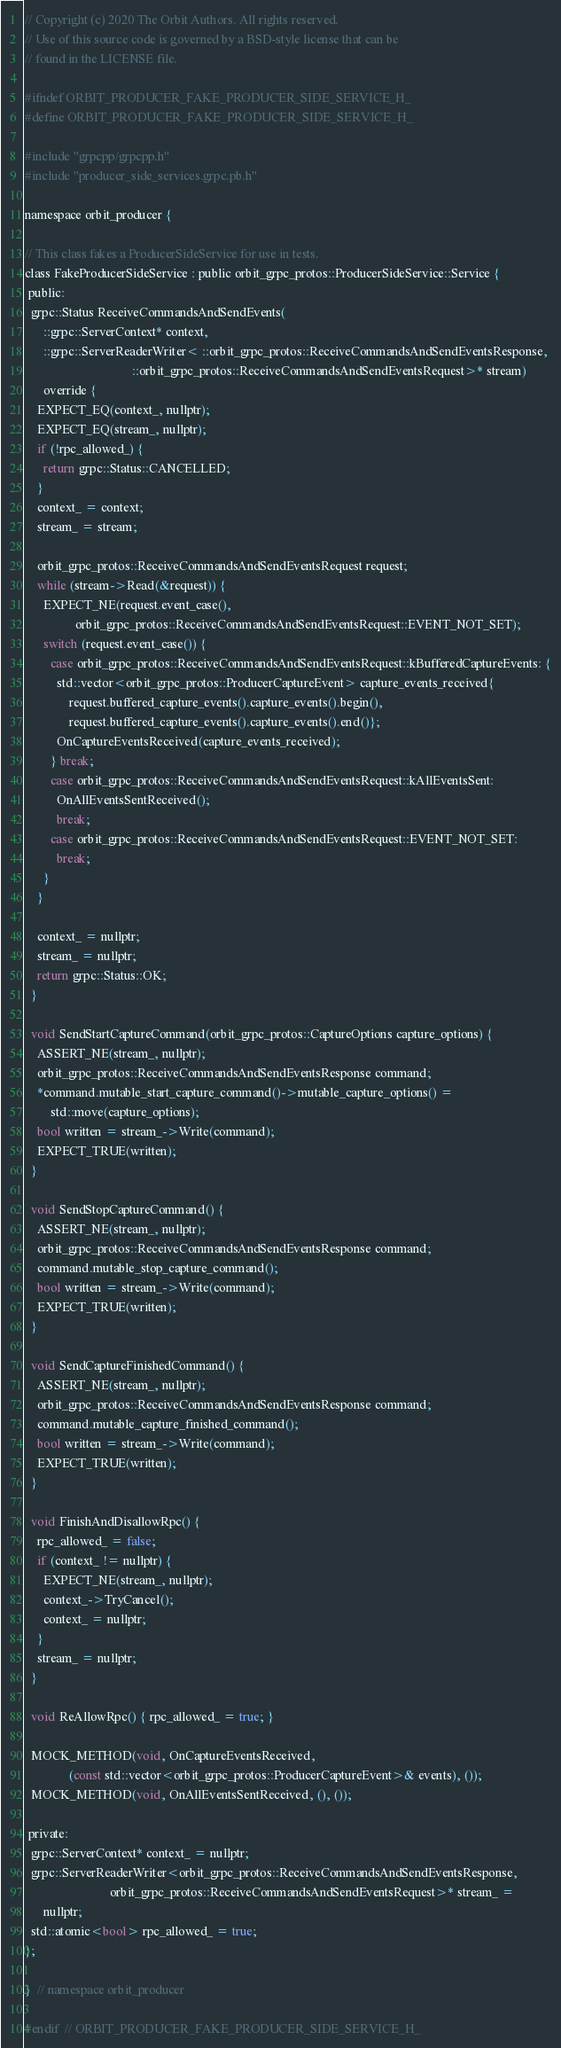Convert code to text. <code><loc_0><loc_0><loc_500><loc_500><_C_>// Copyright (c) 2020 The Orbit Authors. All rights reserved.
// Use of this source code is governed by a BSD-style license that can be
// found in the LICENSE file.

#ifndef ORBIT_PRODUCER_FAKE_PRODUCER_SIDE_SERVICE_H_
#define ORBIT_PRODUCER_FAKE_PRODUCER_SIDE_SERVICE_H_

#include "grpcpp/grpcpp.h"
#include "producer_side_services.grpc.pb.h"

namespace orbit_producer {

// This class fakes a ProducerSideService for use in tests.
class FakeProducerSideService : public orbit_grpc_protos::ProducerSideService::Service {
 public:
  grpc::Status ReceiveCommandsAndSendEvents(
      ::grpc::ServerContext* context,
      ::grpc::ServerReaderWriter< ::orbit_grpc_protos::ReceiveCommandsAndSendEventsResponse,
                                  ::orbit_grpc_protos::ReceiveCommandsAndSendEventsRequest>* stream)
      override {
    EXPECT_EQ(context_, nullptr);
    EXPECT_EQ(stream_, nullptr);
    if (!rpc_allowed_) {
      return grpc::Status::CANCELLED;
    }
    context_ = context;
    stream_ = stream;

    orbit_grpc_protos::ReceiveCommandsAndSendEventsRequest request;
    while (stream->Read(&request)) {
      EXPECT_NE(request.event_case(),
                orbit_grpc_protos::ReceiveCommandsAndSendEventsRequest::EVENT_NOT_SET);
      switch (request.event_case()) {
        case orbit_grpc_protos::ReceiveCommandsAndSendEventsRequest::kBufferedCaptureEvents: {
          std::vector<orbit_grpc_protos::ProducerCaptureEvent> capture_events_received{
              request.buffered_capture_events().capture_events().begin(),
              request.buffered_capture_events().capture_events().end()};
          OnCaptureEventsReceived(capture_events_received);
        } break;
        case orbit_grpc_protos::ReceiveCommandsAndSendEventsRequest::kAllEventsSent:
          OnAllEventsSentReceived();
          break;
        case orbit_grpc_protos::ReceiveCommandsAndSendEventsRequest::EVENT_NOT_SET:
          break;
      }
    }

    context_ = nullptr;
    stream_ = nullptr;
    return grpc::Status::OK;
  }

  void SendStartCaptureCommand(orbit_grpc_protos::CaptureOptions capture_options) {
    ASSERT_NE(stream_, nullptr);
    orbit_grpc_protos::ReceiveCommandsAndSendEventsResponse command;
    *command.mutable_start_capture_command()->mutable_capture_options() =
        std::move(capture_options);
    bool written = stream_->Write(command);
    EXPECT_TRUE(written);
  }

  void SendStopCaptureCommand() {
    ASSERT_NE(stream_, nullptr);
    orbit_grpc_protos::ReceiveCommandsAndSendEventsResponse command;
    command.mutable_stop_capture_command();
    bool written = stream_->Write(command);
    EXPECT_TRUE(written);
  }

  void SendCaptureFinishedCommand() {
    ASSERT_NE(stream_, nullptr);
    orbit_grpc_protos::ReceiveCommandsAndSendEventsResponse command;
    command.mutable_capture_finished_command();
    bool written = stream_->Write(command);
    EXPECT_TRUE(written);
  }

  void FinishAndDisallowRpc() {
    rpc_allowed_ = false;
    if (context_ != nullptr) {
      EXPECT_NE(stream_, nullptr);
      context_->TryCancel();
      context_ = nullptr;
    }
    stream_ = nullptr;
  }

  void ReAllowRpc() { rpc_allowed_ = true; }

  MOCK_METHOD(void, OnCaptureEventsReceived,
              (const std::vector<orbit_grpc_protos::ProducerCaptureEvent>& events), ());
  MOCK_METHOD(void, OnAllEventsSentReceived, (), ());

 private:
  grpc::ServerContext* context_ = nullptr;
  grpc::ServerReaderWriter<orbit_grpc_protos::ReceiveCommandsAndSendEventsResponse,
                           orbit_grpc_protos::ReceiveCommandsAndSendEventsRequest>* stream_ =
      nullptr;
  std::atomic<bool> rpc_allowed_ = true;
};

}  // namespace orbit_producer

#endif  // ORBIT_PRODUCER_FAKE_PRODUCER_SIDE_SERVICE_H_
</code> 